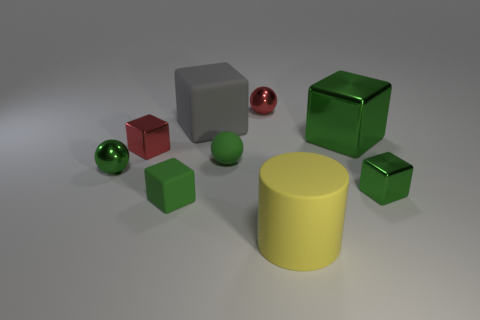Subtract all purple cylinders. How many green cubes are left? 3 Subtract 2 blocks. How many blocks are left? 3 Subtract all red blocks. How many blocks are left? 4 Subtract all large matte cubes. How many cubes are left? 4 Subtract all yellow blocks. Subtract all red cylinders. How many blocks are left? 5 Add 1 large shiny balls. How many objects exist? 10 Subtract all spheres. How many objects are left? 6 Subtract all small yellow matte cylinders. Subtract all metallic spheres. How many objects are left? 7 Add 3 matte spheres. How many matte spheres are left? 4 Add 6 cylinders. How many cylinders exist? 7 